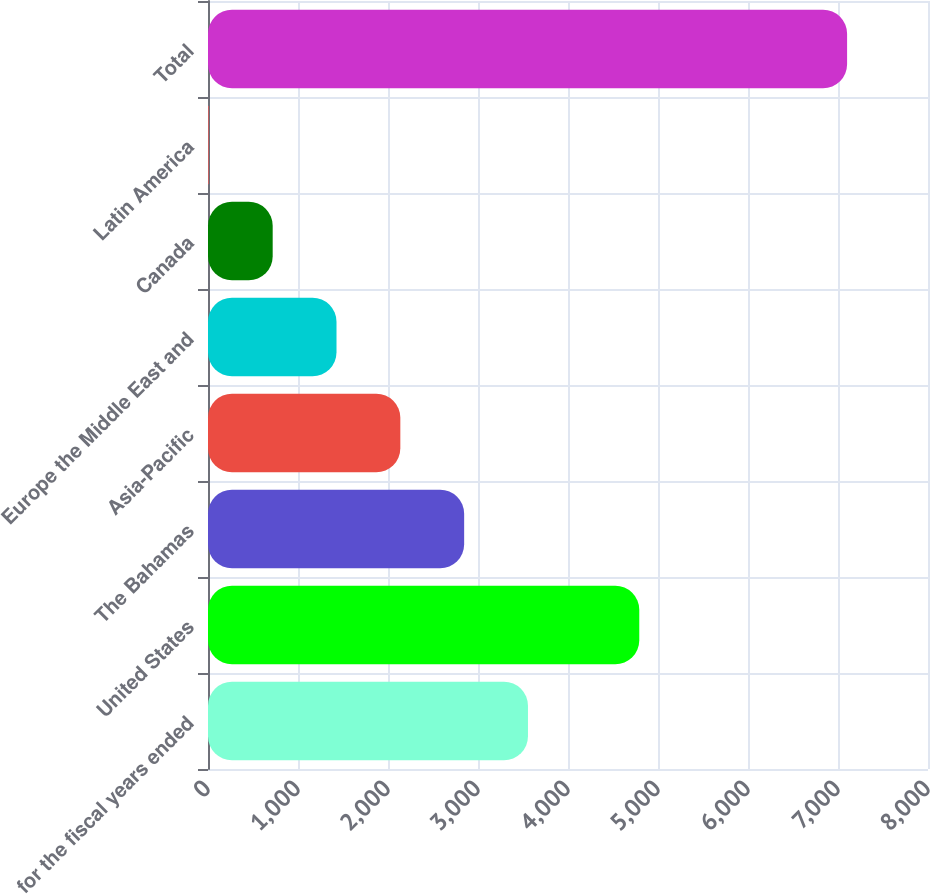Convert chart to OTSL. <chart><loc_0><loc_0><loc_500><loc_500><bar_chart><fcel>for the fiscal years ended<fcel>United States<fcel>The Bahamas<fcel>Asia-Pacific<fcel>Europe the Middle East and<fcel>Canada<fcel>Latin America<fcel>Total<nl><fcel>3555.3<fcel>4791.9<fcel>2846.16<fcel>2137.02<fcel>1427.88<fcel>718.74<fcel>9.6<fcel>7101<nl></chart> 